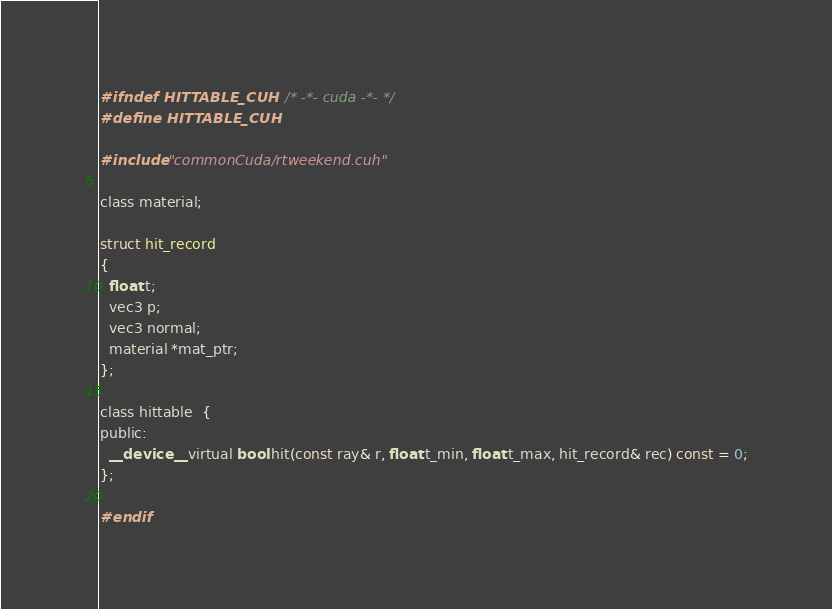<code> <loc_0><loc_0><loc_500><loc_500><_Cuda_>#ifndef HITTABLE_CUH     /* -*- cuda -*- */
#define HITTABLE_CUH

#include "commonCuda/rtweekend.cuh"

class material;

struct hit_record
{
  float t;
  vec3 p;
  vec3 normal;
  material *mat_ptr;
};

class hittable  {
public:
  __device__ virtual bool hit(const ray& r, float t_min, float t_max, hit_record& rec) const = 0;
};

#endif
</code> 